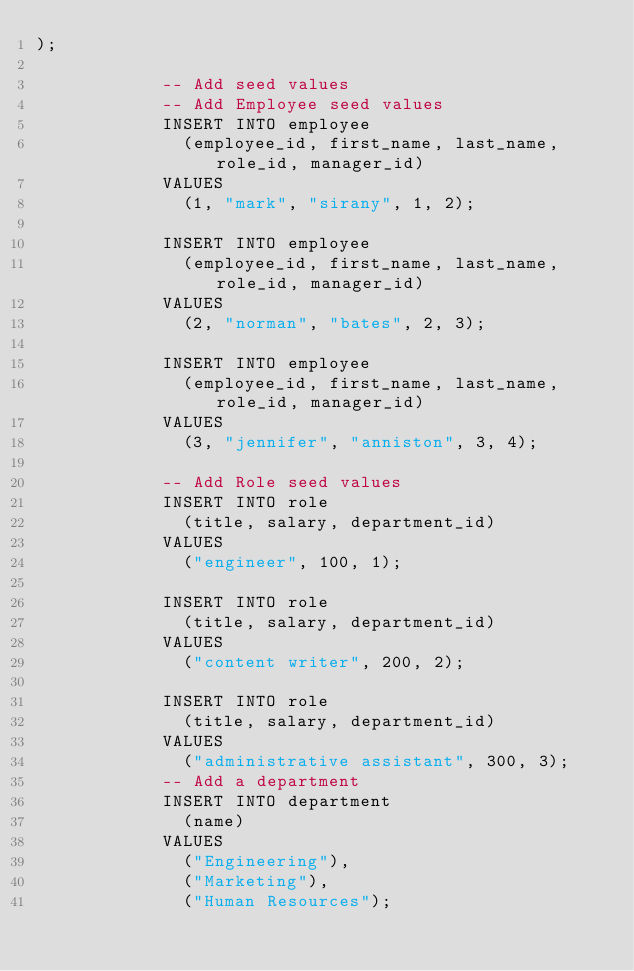Convert code to text. <code><loc_0><loc_0><loc_500><loc_500><_SQL_>);

            -- Add seed values
            -- Add Employee seed values
            INSERT INTO employee
              (employee_id, first_name, last_name, role_id, manager_id)
            VALUES
              (1, "mark", "sirany", 1, 2);

            INSERT INTO employee
              (employee_id, first_name, last_name, role_id, manager_id)
            VALUES
              (2, "norman", "bates", 2, 3);

            INSERT INTO employee
              (employee_id, first_name, last_name, role_id, manager_id)
            VALUES
              (3, "jennifer", "anniston", 3, 4);

            -- Add Role seed values
            INSERT INTO role
              (title, salary, department_id)
            VALUES
              ("engineer", 100, 1);

            INSERT INTO role
              (title, salary, department_id)
            VALUES
              ("content writer", 200, 2);

            INSERT INTO role
              (title, salary, department_id)
            VALUES
              ("administrative assistant", 300, 3);
            -- Add a department
            INSERT INTO department
              (name)
            VALUES
              ("Engineering"),
              ("Marketing"),
              ("Human Resources");
  </code> 